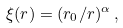Convert formula to latex. <formula><loc_0><loc_0><loc_500><loc_500>\xi ( r ) = ( r _ { 0 } / r ) ^ { \alpha } \, ,</formula> 